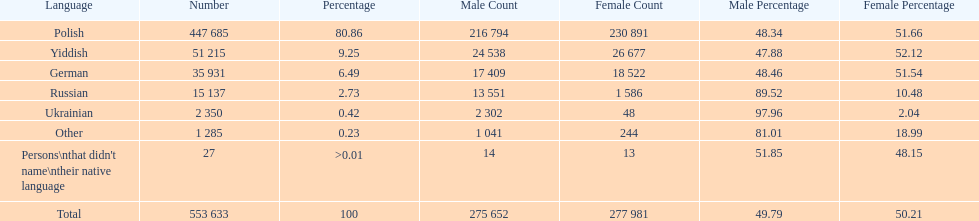Which language did only .42% of people in the imperial census of 1897 speak in the p&#322;ock governorate? Ukrainian. 